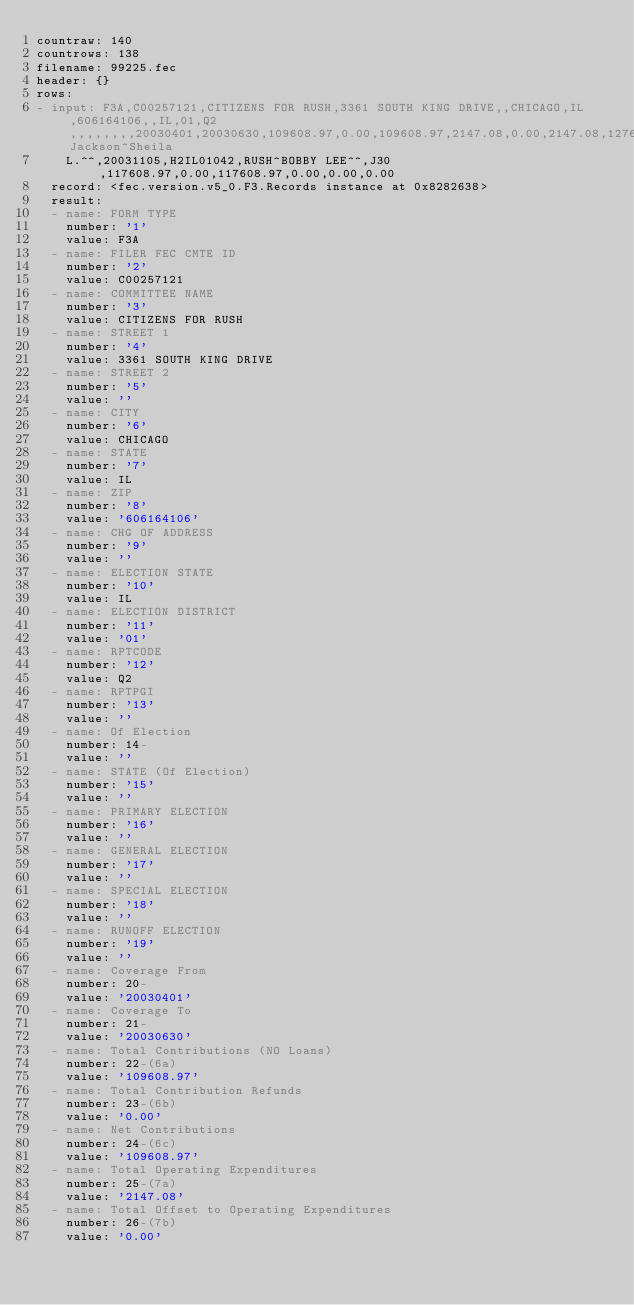Convert code to text. <code><loc_0><loc_0><loc_500><loc_500><_YAML_>countraw: 140
countrows: 138
filename: 99225.fec
header: {}
rows:
- input: F3A,C00257121,CITIZENS FOR RUSH,3361 SOUTH KING DRIVE,,CHICAGO,IL,606164106,,IL,01,Q2,,,,,,,,20030401,20030630,109608.97,0.00,109608.97,2147.08,0.00,2147.08,127681.81,0.00,15195.51,67100.00,3175.00,70275.00,0.00,39333.97,0.00,109608.97,0.00,0.00,0.00,0.00,0.00,0.00,109608.97,2147.08,0.00,0.00,0.00,0.00,0.00,0.00,0.00,0.00,19790.89,21937.97,40010.81,109608.97,149619.78,21937.97,127681.81,123448.97,304.56,123144.41,28231.68,0.00,28231.68,73100.00,3515.00,76615.00,0.00,46833.97,0.00,123448.97,0.00,0.00,0.00,0.00,0.00,21661.51,145110.48,28231.68,0.00,0.00,0.00,0.00,0.00,0.00,304.56,304.56,23290.89,51827.13,Jackson^Sheila
    L.^^,20031105,H2IL01042,RUSH^BOBBY LEE^^,J30,117608.97,0.00,117608.97,0.00,0.00,0.00
  record: <fec.version.v5_0.F3.Records instance at 0x8282638>
  result:
  - name: FORM TYPE
    number: '1'
    value: F3A
  - name: FILER FEC CMTE ID
    number: '2'
    value: C00257121
  - name: COMMITTEE NAME
    number: '3'
    value: CITIZENS FOR RUSH
  - name: STREET 1
    number: '4'
    value: 3361 SOUTH KING DRIVE
  - name: STREET 2
    number: '5'
    value: ''
  - name: CITY
    number: '6'
    value: CHICAGO
  - name: STATE
    number: '7'
    value: IL
  - name: ZIP
    number: '8'
    value: '606164106'
  - name: CHG OF ADDRESS
    number: '9'
    value: ''
  - name: ELECTION STATE
    number: '10'
    value: IL
  - name: ELECTION DISTRICT
    number: '11'
    value: '01'
  - name: RPTCODE
    number: '12'
    value: Q2
  - name: RPTPGI
    number: '13'
    value: ''
  - name: Of Election
    number: 14-
    value: ''
  - name: STATE (Of Election)
    number: '15'
    value: ''
  - name: PRIMARY ELECTION
    number: '16'
    value: ''
  - name: GENERAL ELECTION
    number: '17'
    value: ''
  - name: SPECIAL ELECTION
    number: '18'
    value: ''
  - name: RUNOFF ELECTION
    number: '19'
    value: ''
  - name: Coverage From
    number: 20-
    value: '20030401'
  - name: Coverage To
    number: 21-
    value: '20030630'
  - name: Total Contributions (NO Loans)
    number: 22-(6a)
    value: '109608.97'
  - name: Total Contribution Refunds
    number: 23-(6b)
    value: '0.00'
  - name: Net Contributions
    number: 24-(6c)
    value: '109608.97'
  - name: Total Operating Expenditures
    number: 25-(7a)
    value: '2147.08'
  - name: Total Offset to Operating Expenditures
    number: 26-(7b)
    value: '0.00'</code> 